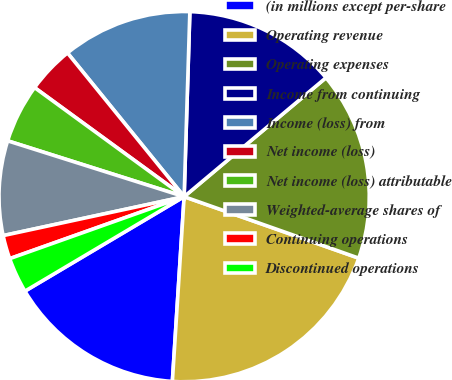Convert chart to OTSL. <chart><loc_0><loc_0><loc_500><loc_500><pie_chart><fcel>(in millions except per-share<fcel>Operating revenue<fcel>Operating expenses<fcel>Income from continuing<fcel>Income (loss) from<fcel>Net income (loss)<fcel>Net income (loss) attributable<fcel>Weighted-average shares of<fcel>Continuing operations<fcel>Discontinued operations<nl><fcel>15.46%<fcel>20.62%<fcel>16.49%<fcel>13.4%<fcel>11.34%<fcel>4.12%<fcel>5.15%<fcel>8.25%<fcel>2.06%<fcel>3.09%<nl></chart> 